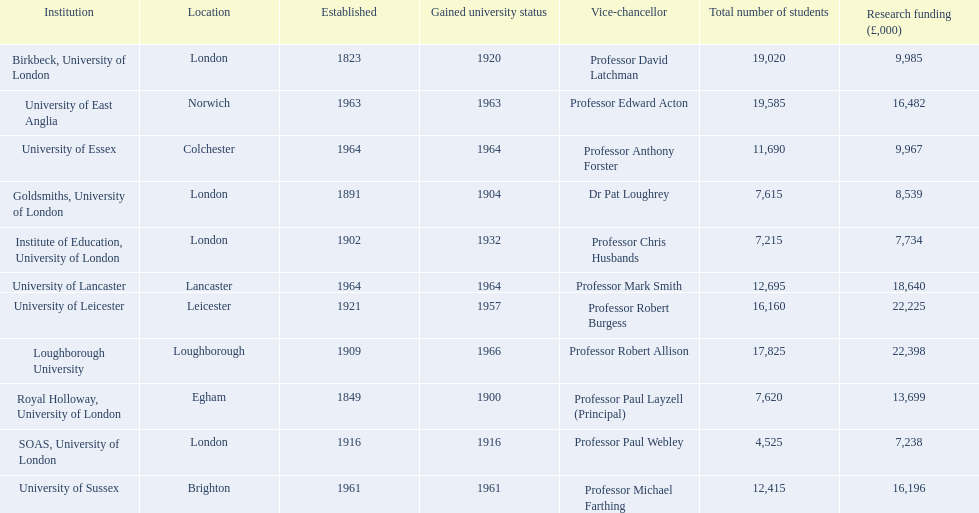Where can birkbeck, university of london be found? London. Which university came into existence in 1921? University of Leicester. Which organization has freshly obtained university status? Loughborough University. 